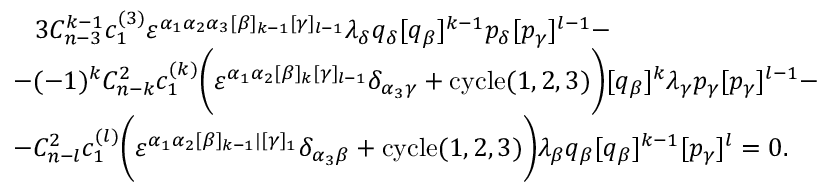Convert formula to latex. <formula><loc_0><loc_0><loc_500><loc_500>\begin{array} { l } { { \, 3 C _ { n - 3 } ^ { k - 1 } c _ { 1 } ^ { ( 3 ) } \varepsilon ^ { \alpha _ { 1 } \alpha _ { 2 } \alpha _ { 3 } [ \beta ] _ { k - 1 } [ \gamma ] _ { l - 1 } } \lambda _ { \delta } q _ { \delta } [ q _ { \beta } ] ^ { k - 1 } p _ { \delta } [ p _ { \gamma } ] ^ { l - 1 } - } } \\ { { - ( - 1 ) ^ { k } C _ { n - k } ^ { 2 } c _ { 1 } ^ { ( k ) } \left ( \varepsilon ^ { \alpha _ { 1 } \alpha _ { 2 } [ \beta ] _ { k } [ \gamma ] _ { l - 1 } } \delta _ { \alpha _ { 3 } \gamma } + c y c l e ( 1 , 2 , 3 ) \right ) [ q _ { \beta } ] ^ { k } \lambda _ { \gamma } p _ { \gamma } [ p _ { \gamma } ] ^ { l - 1 } - } } \\ { { - C _ { n - l } ^ { 2 } c _ { 1 } ^ { ( l ) } \left ( \varepsilon ^ { \alpha _ { 1 } \alpha _ { 2 } [ \beta ] _ { k - 1 } | [ \gamma ] _ { 1 } } \delta _ { \alpha _ { 3 } \beta } + c y c l e ( 1 , 2 , 3 ) \right ) \lambda _ { \beta } q _ { \beta } [ q _ { \beta } ] ^ { k - 1 } [ p _ { \gamma } ] ^ { l } = 0 . } } \end{array}</formula> 